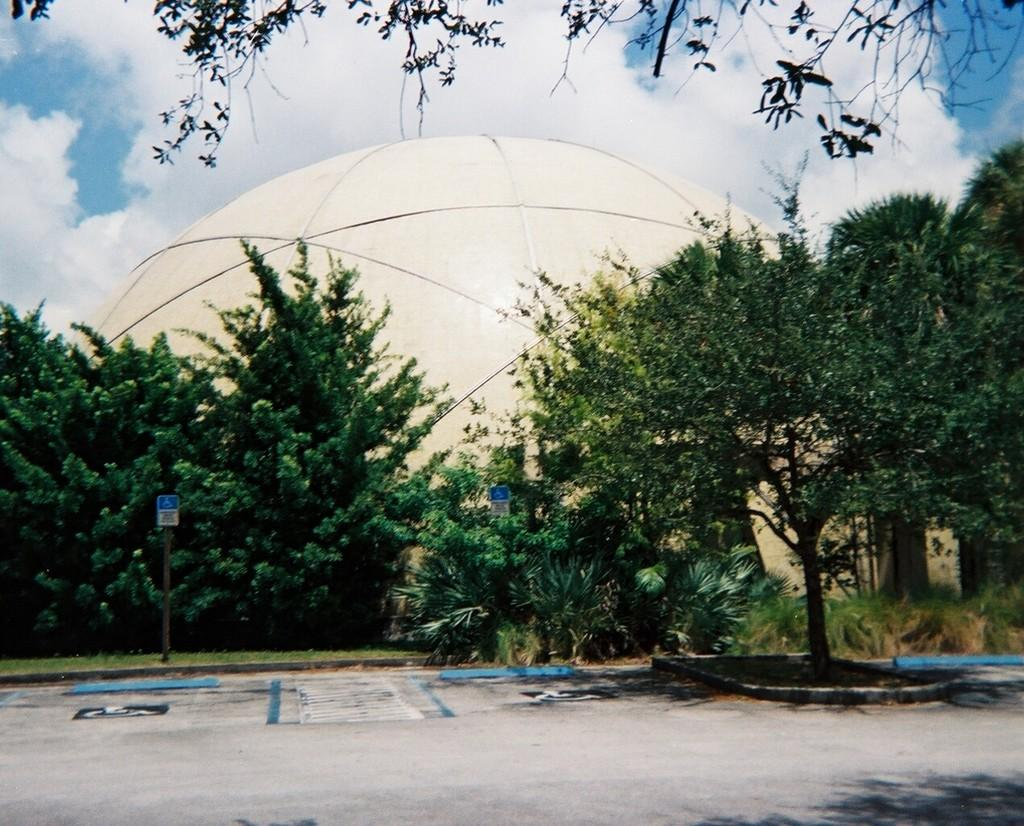What can be seen in the foreground of the image? In the foreground of the image, there is a path to walk, trees, poles, and a dome. What is the surface that people might walk on in the image? The path in the foreground of the image is a surface that people might walk on. What is visible in the sky in the image? The sky is visible at the top of the image, and there are clouds visible in the sky. Can you tell me how many cactus plants are growing on the floor in the image? There are no cactus plants visible in the image. How does the dome move around in the image? The dome does not move around in the image; it is stationary. 